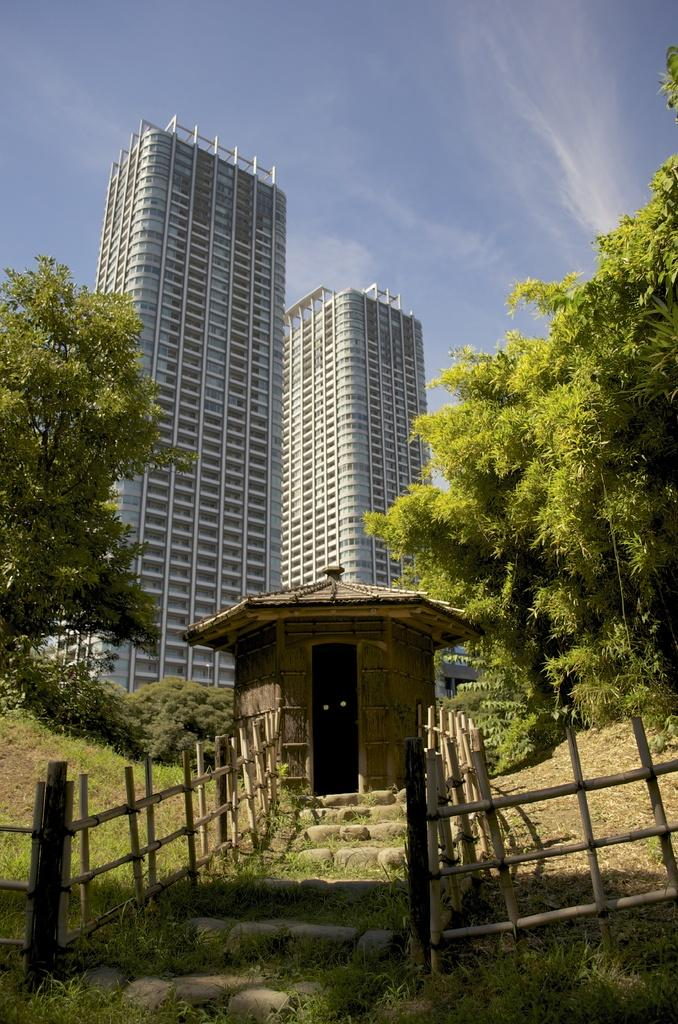What structure is located in the center of the image? There is a hut with stairs in the center of the image. What type of barrier can be seen in the image? There is a wooden fence in the image. What type of vegetation is present in the image? Grass is present in the image. What type of natural elements are visible in the image? Trees are visible in the image. What can be seen in the background of the image? There are buildings and the sky visible in the background of the image. Where is the volleyball court located in the image? There is no volleyball court present in the image. Who is wearing the crown in the image? There is no crown or person wearing a crown present in the image. 